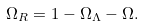<formula> <loc_0><loc_0><loc_500><loc_500>\Omega _ { R } = 1 - \Omega _ { \Lambda } - \Omega .</formula> 